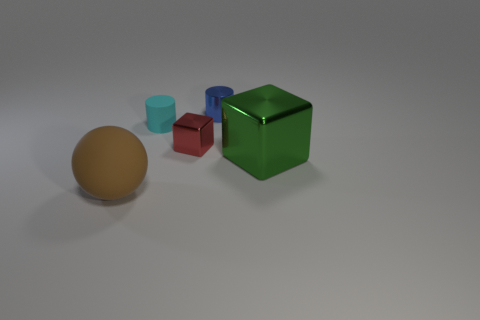Does the green block have the same size as the blue cylinder?
Make the answer very short. No. What material is the large green block?
Make the answer very short. Metal. There is a block that is the same material as the large green thing; what color is it?
Keep it short and to the point. Red. Is the large ball made of the same material as the small cylinder that is on the left side of the red block?
Offer a very short reply. Yes. How many other small things have the same material as the small red thing?
Provide a short and direct response. 1. What shape is the matte thing that is right of the sphere?
Make the answer very short. Cylinder. Do the cylinder that is on the left side of the blue object and the cube that is behind the large green metallic thing have the same material?
Provide a short and direct response. No. Is there a small cyan object that has the same shape as the tiny blue thing?
Ensure brevity in your answer.  Yes. What number of objects are either things behind the cyan thing or big yellow objects?
Give a very brief answer. 1. Are there more tiny cyan rubber cylinders in front of the tiny cyan thing than tiny objects that are on the right side of the green metallic object?
Make the answer very short. No. 